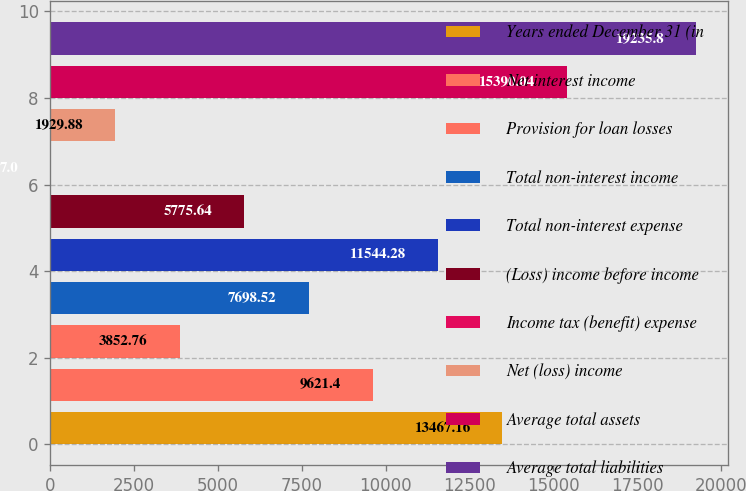<chart> <loc_0><loc_0><loc_500><loc_500><bar_chart><fcel>Years ended December 31 (in<fcel>Net interest income<fcel>Provision for loan losses<fcel>Total non-interest income<fcel>Total non-interest expense<fcel>(Loss) income before income<fcel>Income tax (benefit) expense<fcel>Net (loss) income<fcel>Average total assets<fcel>Average total liabilities<nl><fcel>13467.2<fcel>9621.4<fcel>3852.76<fcel>7698.52<fcel>11544.3<fcel>5775.64<fcel>7<fcel>1929.88<fcel>15390<fcel>19235.8<nl></chart> 